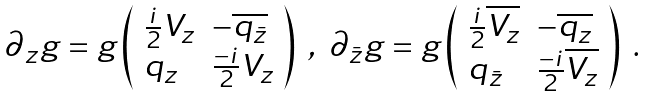<formula> <loc_0><loc_0><loc_500><loc_500>\begin{array} { l } \partial _ { z } g = g \left ( \begin{array} { l l } \frac { i } { 2 } V _ { z } & - \overline { q _ { \bar { z } } } \\ q _ { z } & \frac { - i } { 2 } V _ { z } \end{array} \right ) \ , \ \partial _ { \bar { z } } g = g \left ( \begin{array} { l l } \frac { i } { 2 } \overline { V _ { z } } & - \overline { q _ { z } } \\ q _ { \bar { z } } & \frac { - i } { 2 } \overline { V _ { z } } \end{array} \right ) \ . \end{array}</formula> 